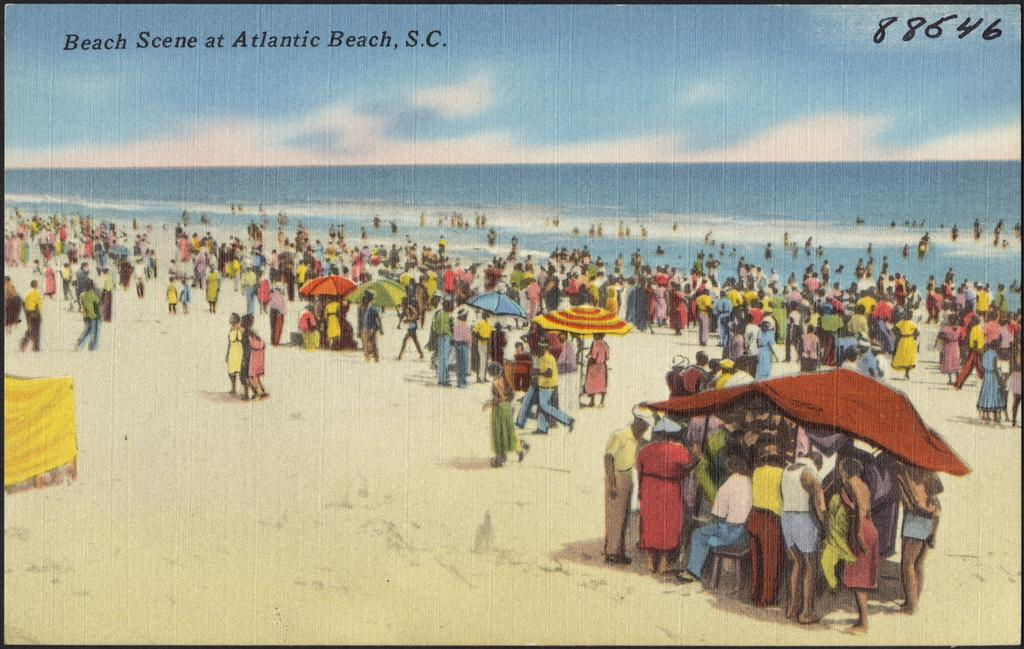Provide a one-sentence caption for the provided image. An old postcard of Atlantic Beach, S.C. with the number88646 handwritten on it. 